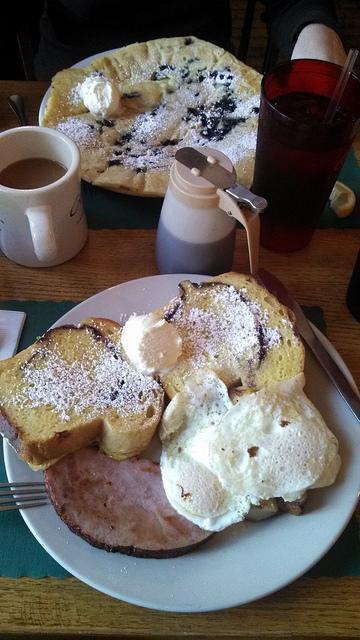How many sandwiches are in the picture?
Give a very brief answer. 2. How many cups are in the picture?
Give a very brief answer. 2. 